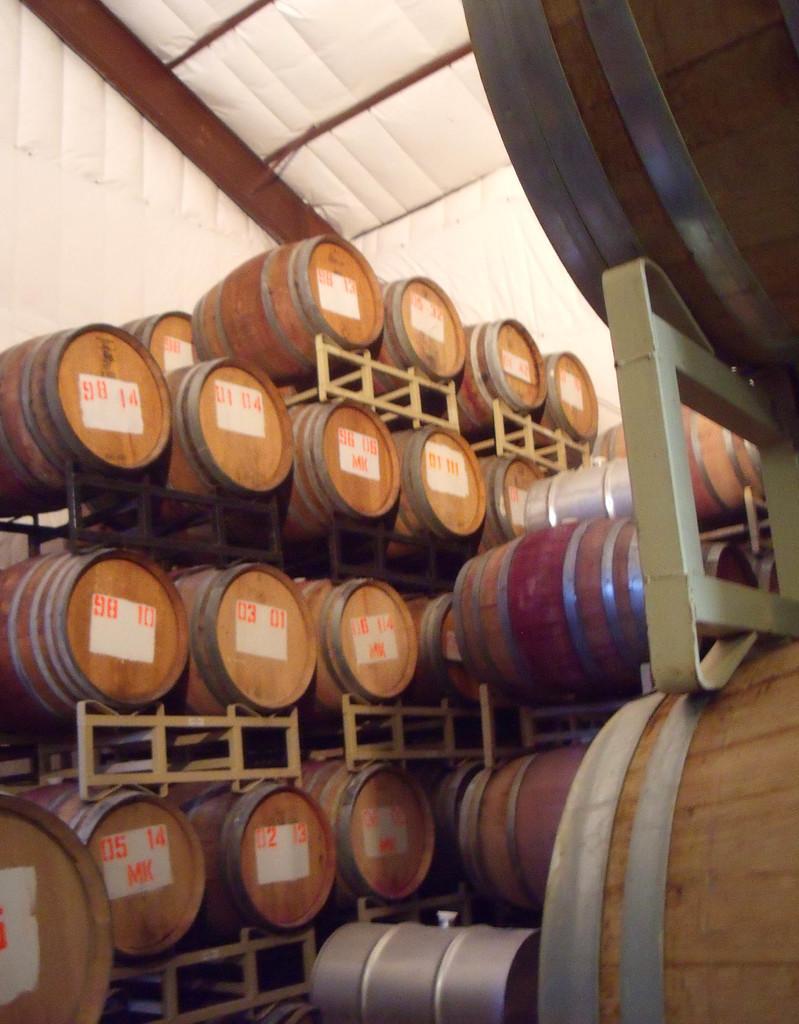Describe this image in one or two sentences. In this image, we can see wooden barrels are placed on the rod stands. On few wooden barrels, we can see numbers and letters. Background we can see white color objects and rods. 